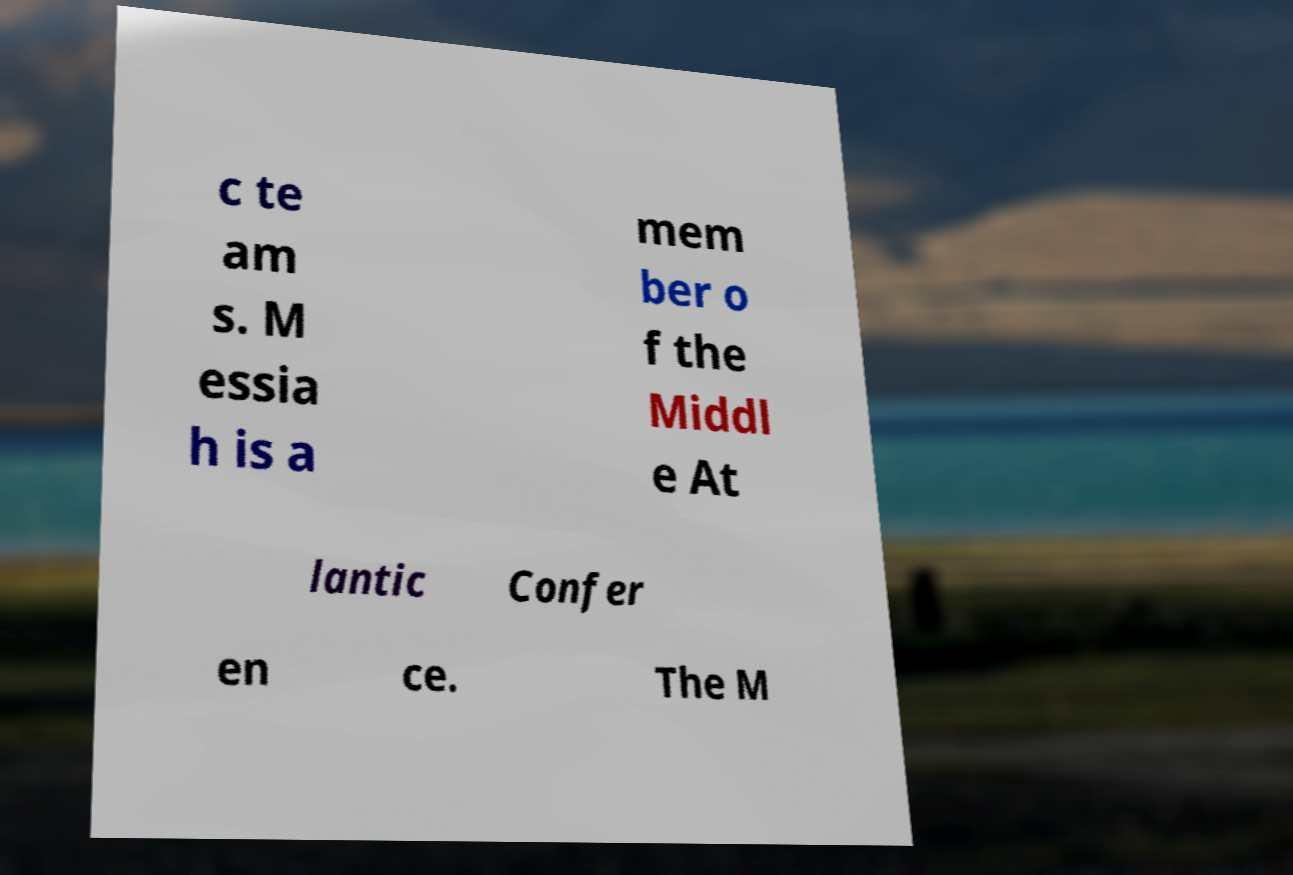Could you extract and type out the text from this image? c te am s. M essia h is a mem ber o f the Middl e At lantic Confer en ce. The M 